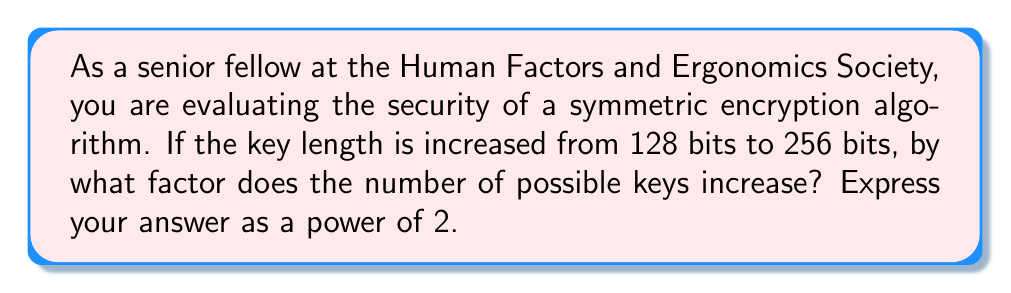What is the answer to this math problem? Let's approach this step-by-step:

1) For a key of length $n$ bits, the number of possible keys is $2^n$.

2) For a 128-bit key:
   Number of possible keys = $2^{128}$

3) For a 256-bit key:
   Number of possible keys = $2^{256}$

4) To find the factor by which the number of keys increases, we divide the number of keys for 256 bits by the number of keys for 128 bits:

   $\frac{2^{256}}{2^{128}}$

5) Using the laws of exponents, when dividing powers with the same base, we subtract the exponents:

   $2^{256-128} = 2^{128}$

Therefore, the number of possible keys increases by a factor of $2^{128}$.

This demonstrates that doubling the key length results in an exponential increase in the number of possible keys, significantly enhancing the security of the encryption algorithm against brute-force attacks.
Answer: $2^{128}$ 